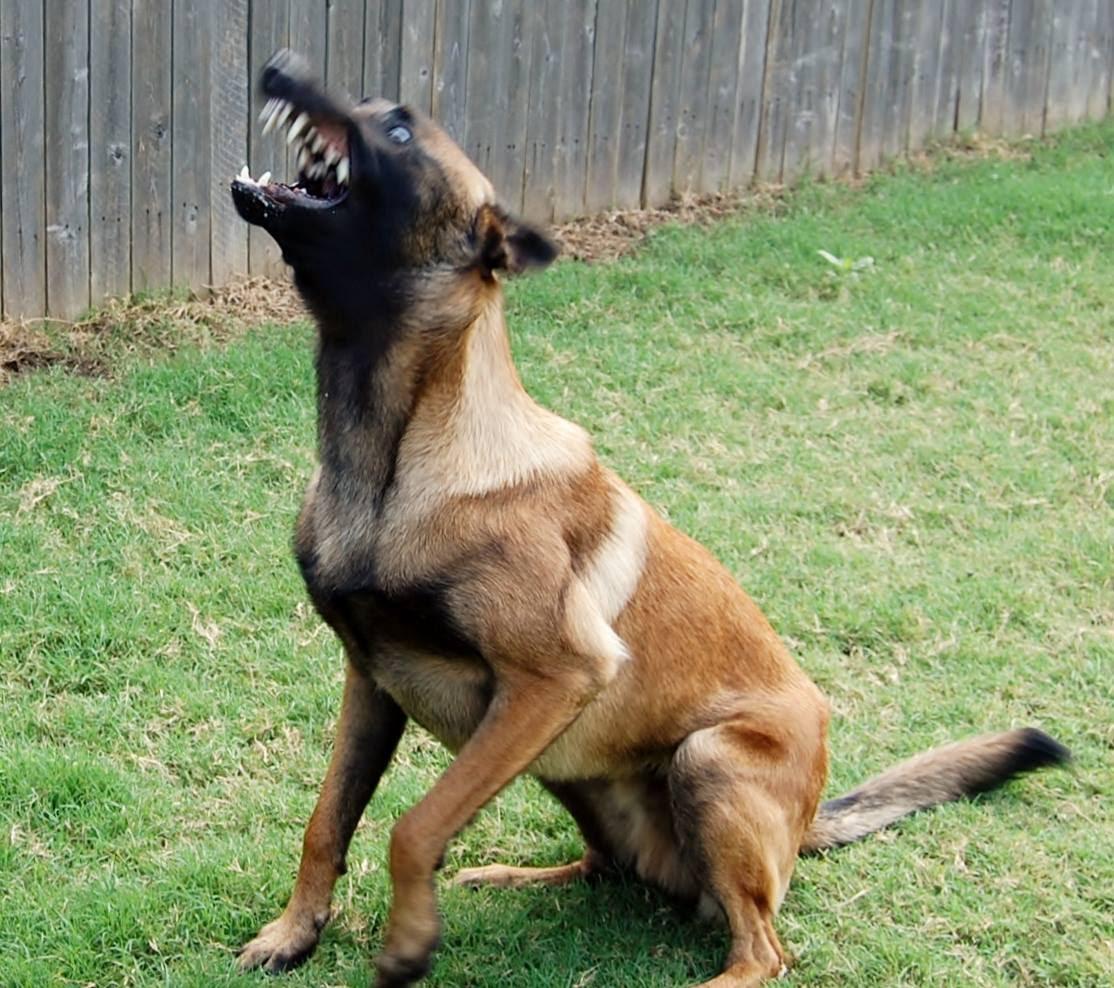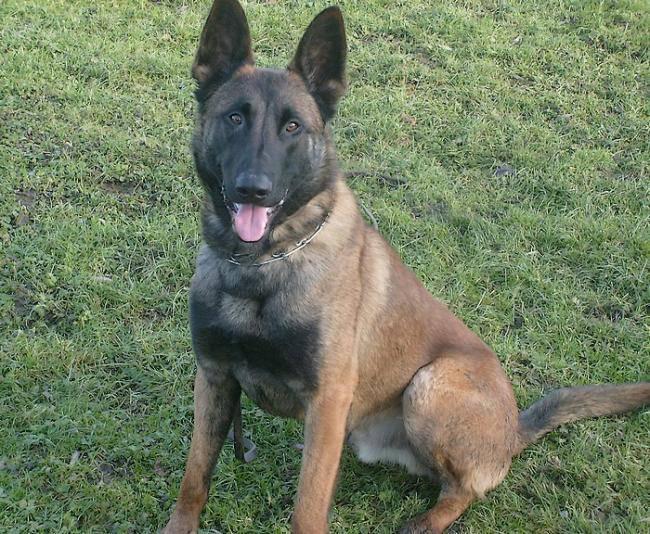The first image is the image on the left, the second image is the image on the right. Considering the images on both sides, is "In one image od each pair a lone dog is standing still on grass." valid? Answer yes or no. No. The first image is the image on the left, the second image is the image on the right. Considering the images on both sides, is "There is one dog standing still on all fours in the stacked position." valid? Answer yes or no. No. 